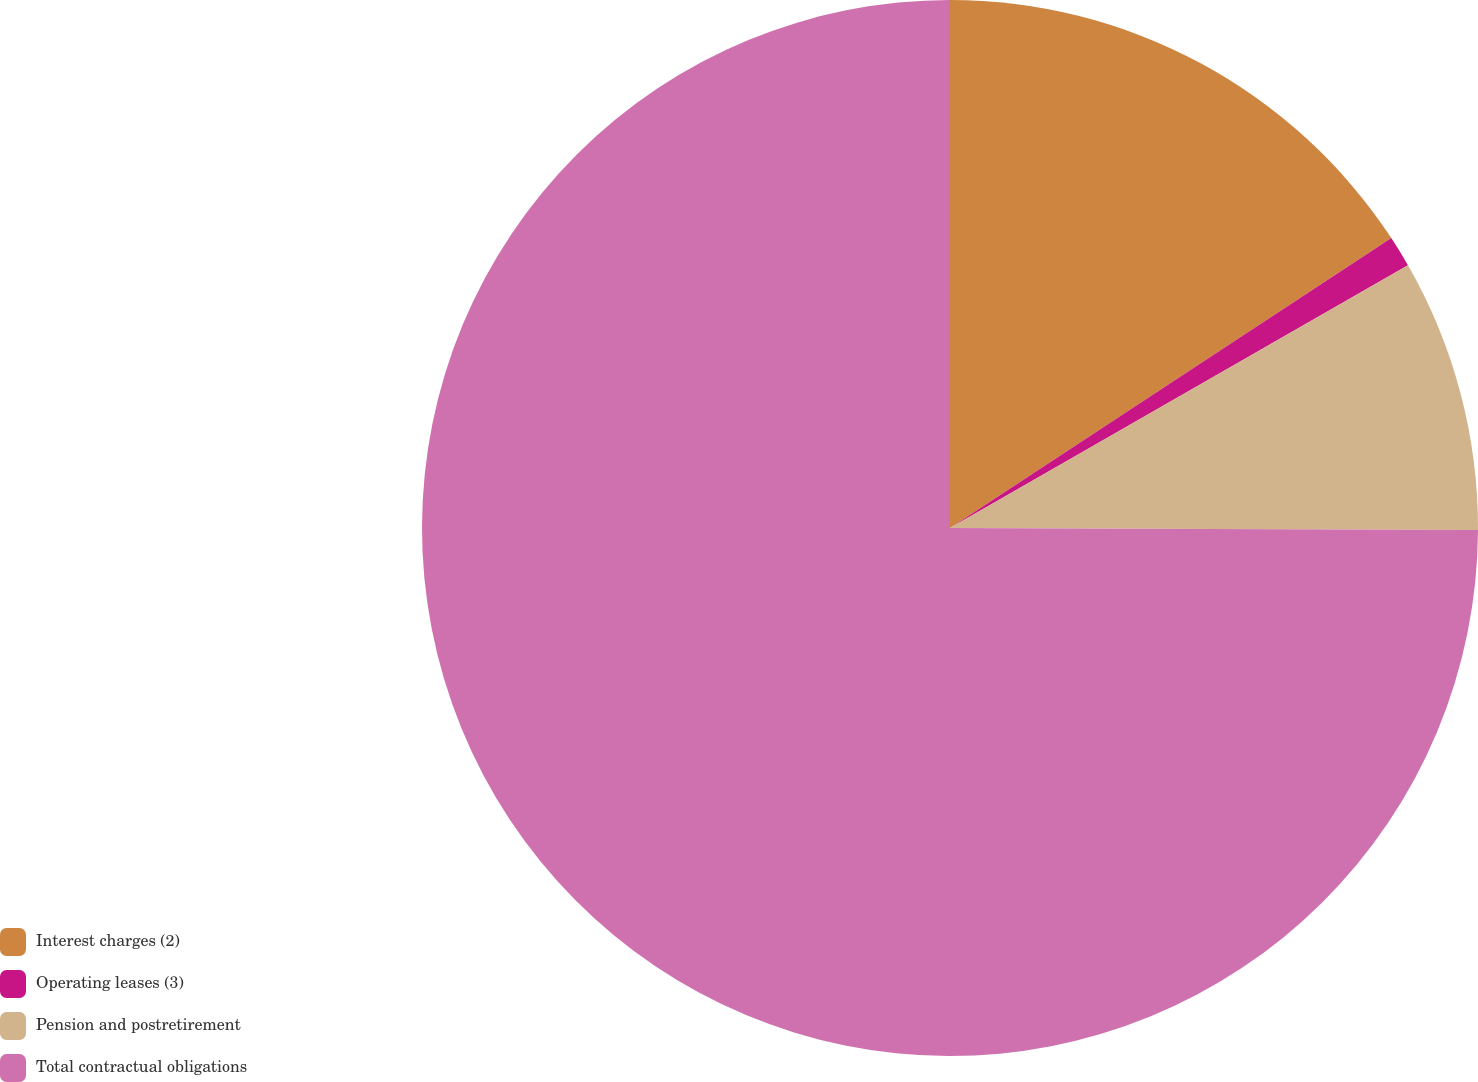<chart> <loc_0><loc_0><loc_500><loc_500><pie_chart><fcel>Interest charges (2)<fcel>Operating leases (3)<fcel>Pension and postretirement<fcel>Total contractual obligations<nl><fcel>15.75%<fcel>0.96%<fcel>8.35%<fcel>74.94%<nl></chart> 